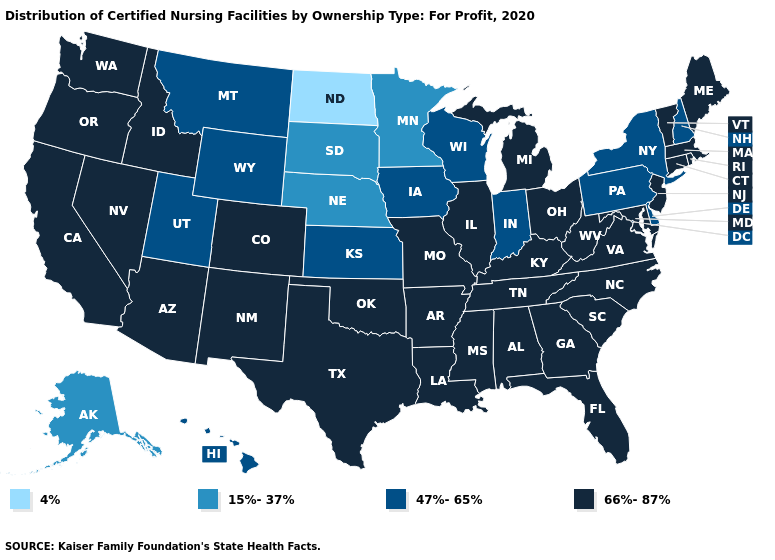Among the states that border Maryland , which have the highest value?
Concise answer only. Virginia, West Virginia. Does Louisiana have the highest value in the USA?
Be succinct. Yes. What is the lowest value in the South?
Be succinct. 47%-65%. What is the value of Wisconsin?
Answer briefly. 47%-65%. Does the map have missing data?
Keep it brief. No. What is the highest value in the West ?
Answer briefly. 66%-87%. What is the highest value in states that border Kansas?
Answer briefly. 66%-87%. What is the value of Washington?
Answer briefly. 66%-87%. Does South Dakota have a higher value than North Dakota?
Answer briefly. Yes. What is the value of New Mexico?
Concise answer only. 66%-87%. Among the states that border Vermont , which have the highest value?
Write a very short answer. Massachusetts. Name the states that have a value in the range 66%-87%?
Short answer required. Alabama, Arizona, Arkansas, California, Colorado, Connecticut, Florida, Georgia, Idaho, Illinois, Kentucky, Louisiana, Maine, Maryland, Massachusetts, Michigan, Mississippi, Missouri, Nevada, New Jersey, New Mexico, North Carolina, Ohio, Oklahoma, Oregon, Rhode Island, South Carolina, Tennessee, Texas, Vermont, Virginia, Washington, West Virginia. What is the highest value in the South ?
Be succinct. 66%-87%. Does Oklahoma have a lower value than Wyoming?
Quick response, please. No. Which states hav the highest value in the South?
Write a very short answer. Alabama, Arkansas, Florida, Georgia, Kentucky, Louisiana, Maryland, Mississippi, North Carolina, Oklahoma, South Carolina, Tennessee, Texas, Virginia, West Virginia. 